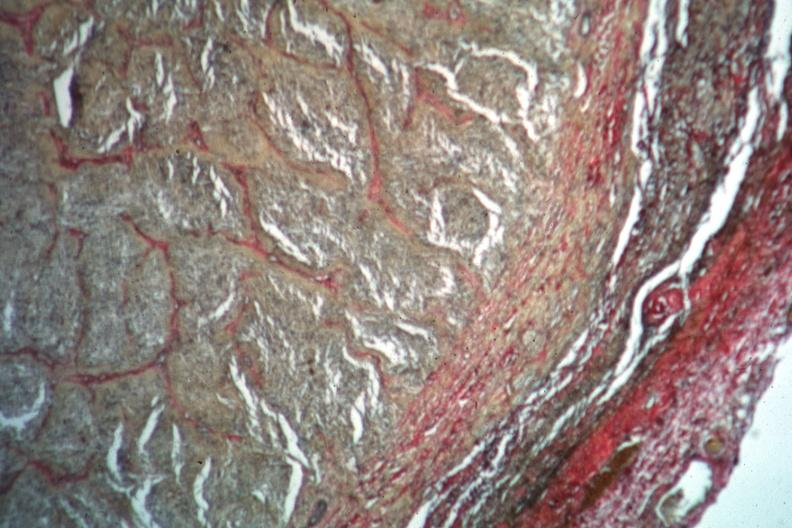s lymphangiomatosis present?
Answer the question using a single word or phrase. No 